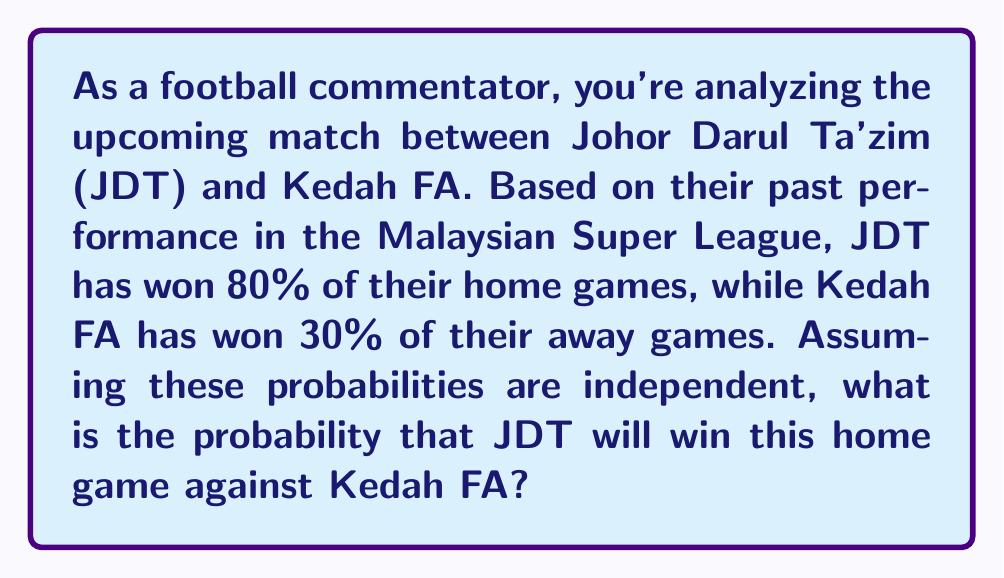Can you answer this question? Let's approach this step-by-step:

1) First, we need to understand what the question is asking. We're looking for the probability of JDT winning, given that they're playing at home.

2) We're given two probabilities:
   - P(JDT wins at home) = 0.80
   - P(Kedah FA wins away) = 0.30

3) To find the probability of JDT winning, we need to consider the complement of Kedah FA winning:
   P(Kedah FA doesn't win) = 1 - P(Kedah FA wins) = 1 - 0.30 = 0.70

4) Now, assuming independence (as stated in the question), the probability of JDT winning is the product of:
   - The probability that JDT wins at home
   - The probability that Kedah FA doesn't win away

5) We can express this mathematically as:

   $$P(\text{JDT wins}) = P(\text{JDT wins at home}) \times P(\text{Kedah FA doesn't win away})$$

6) Substituting the values:

   $$P(\text{JDT wins}) = 0.80 \times 0.70 = 0.56$$

7) Therefore, the probability of JDT winning this home game against Kedah FA is 0.56 or 56%.
Answer: 0.56 